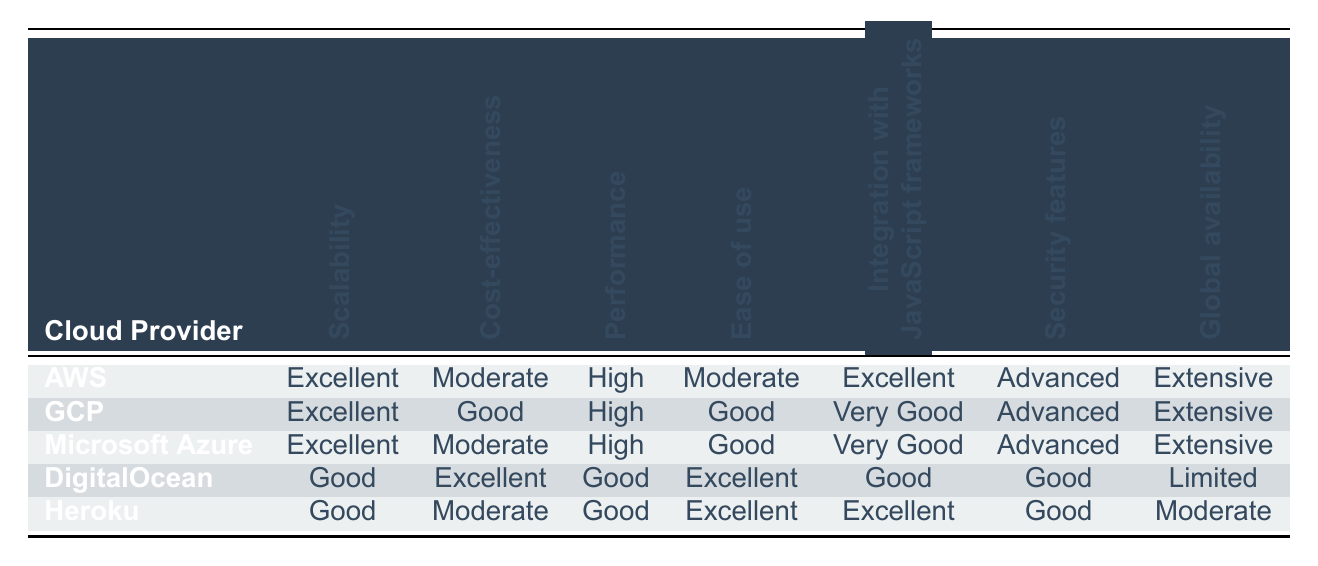What is the scalability rating of DigitalOcean? According to the table, DigitalOcean has a scalability rating of "Good." This is found in the 'Scalability' column corresponding to the 'DigitalOcean' row.
Answer: Good Which cloud provider has the highest performance rating? Both Amazon Web Services (AWS), Google Cloud Platform (GCP), and Microsoft Azure have a performance rating of "High." This indicates they perform equally well according to the table, listed in the 'Performance' column.
Answer: AWS, GCP, Microsoft Azure Is it true that Heroku has advanced security features? According to the table, Heroku has a security features rating of "Good," not "Advanced." Hence, the statement is false.
Answer: False How does the cost-effectiveness of DigitalOcean compare to Heroku? DigitalOcean has a cost-effectiveness rating of "Excellent," while Heroku has a rating of "Moderate." Therefore, DigitalOcean is more cost-effective than Heroku.
Answer: DigitalOcean is more cost-effective What is the median ease of use rating across all cloud providers? The ease of use ratings are: AWS (Moderate), GCP (Good), Microsoft Azure (Good), DigitalOcean (Excellent), and Heroku (Excellent). If we convert these ratings to numerical values (Moderate=2, Good=3, Excellent=4), we get 2, 3, 3, 4, 4. The sorted ratings are 2, 3, 3, 4, 4. The median (middle value) is 3.
Answer: 3 Which cloud provider has the best capabilities for integrating with JavaScript frameworks? The table indicates that Amazon Web Services (AWS) and Heroku have ratings of "Excellent" for integration with JavaScript frameworks, while GCP has "Very Good." Therefore, AWS and Heroku are the best options in this category.
Answer: AWS, Heroku Is Google Cloud Platform globally available? The table shows that Google Cloud Platform (GCP) has a global availability rating of "Extensive," confirming it is globally available.
Answer: Yes Which cloud provider offers the least global availability? Based on the table, DigitalOcean is the provider with the least global availability, rated as "Limited." This is found in the 'Global availability' column.
Answer: DigitalOcean 